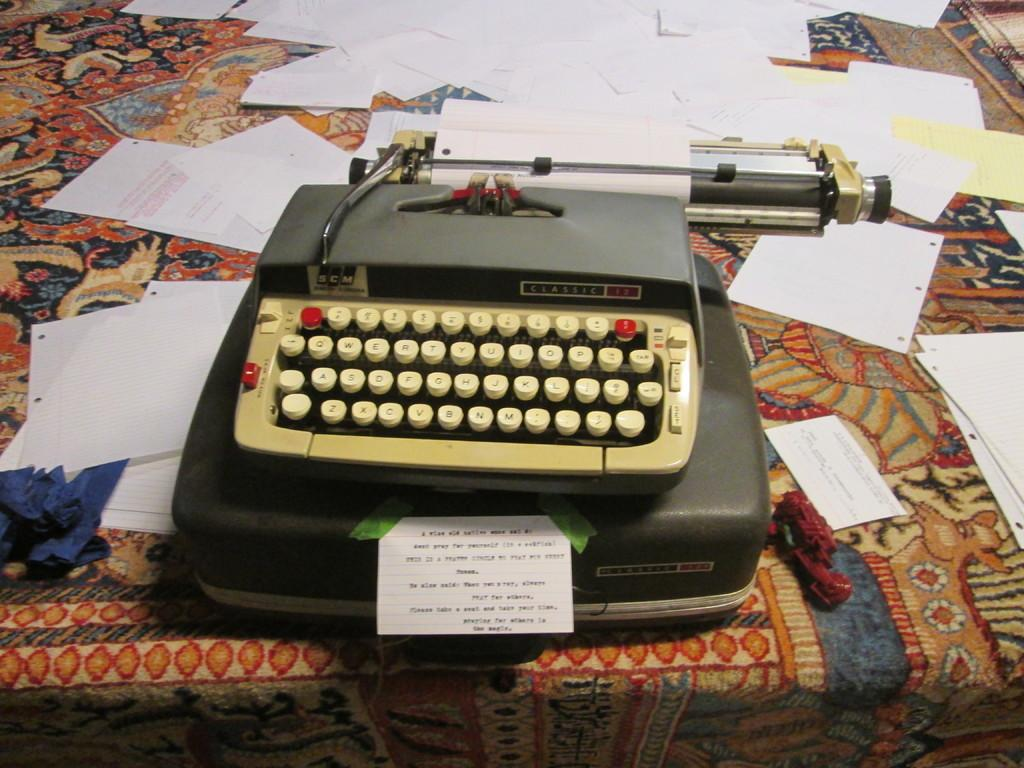<image>
Present a compact description of the photo's key features. a typewriter that has the letter B at the bottom 